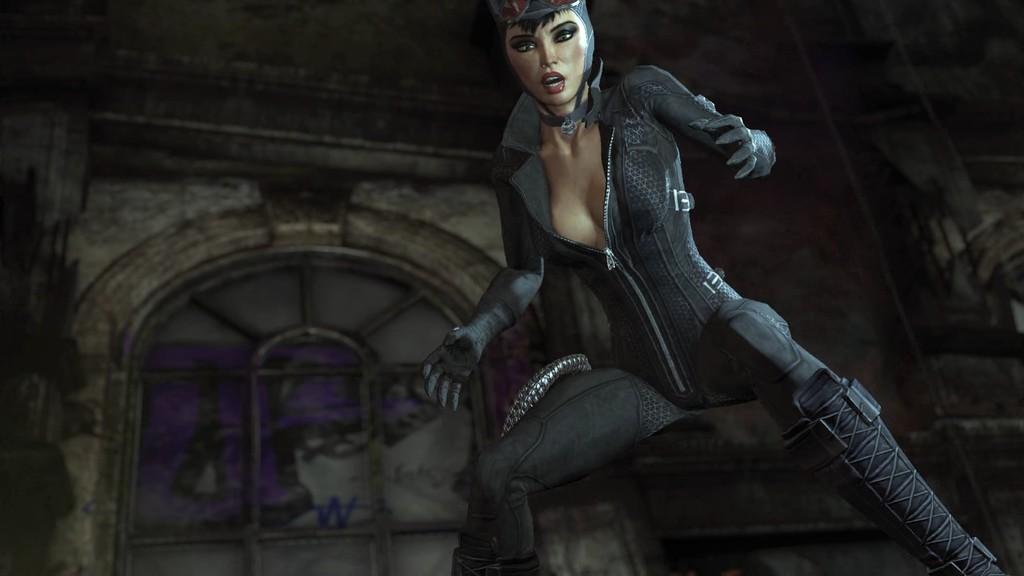Describe this image in one or two sentences. This is an animated image. In this image we can see a woman standing. On the backside we can see a window and a wall. 